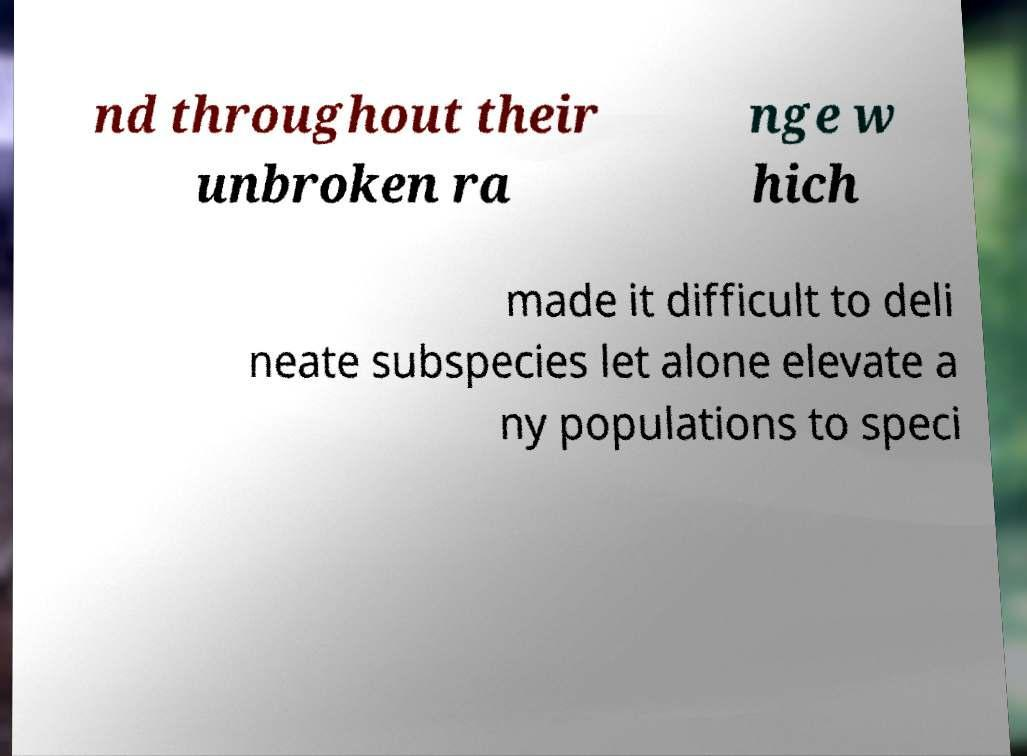Please identify and transcribe the text found in this image. nd throughout their unbroken ra nge w hich made it difficult to deli neate subspecies let alone elevate a ny populations to speci 